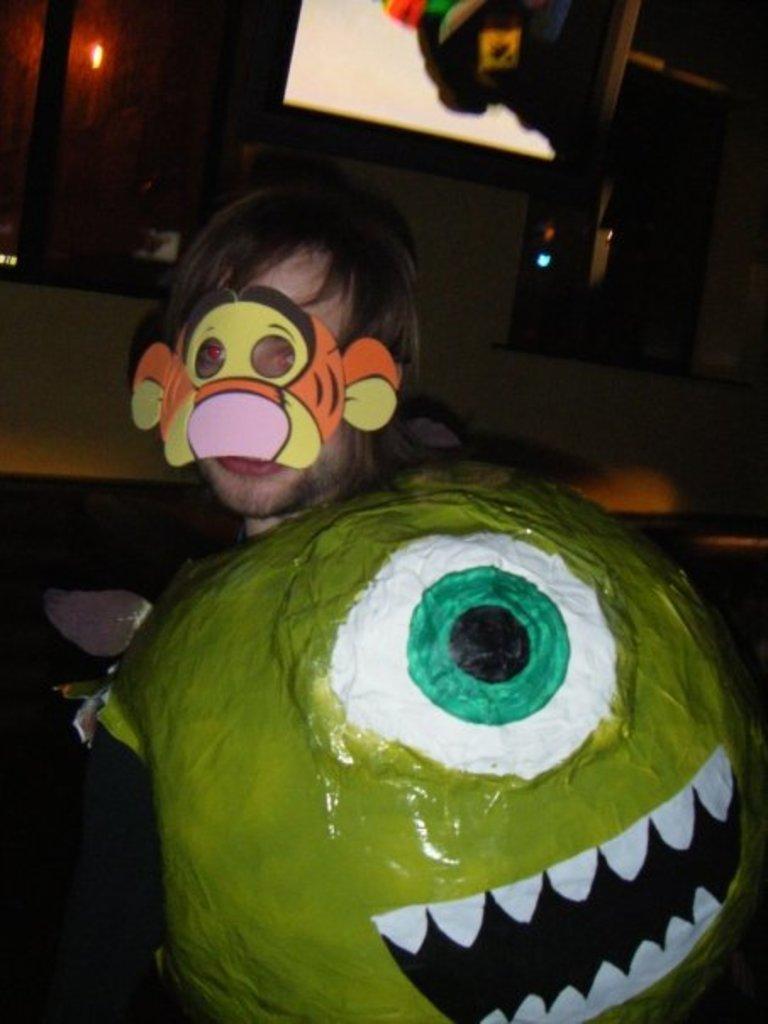How would you summarize this image in a sentence or two? In this image there is a person wearing mask on his face, in front of the person on the wall there is glass windows, at the top of the image there is a television. 